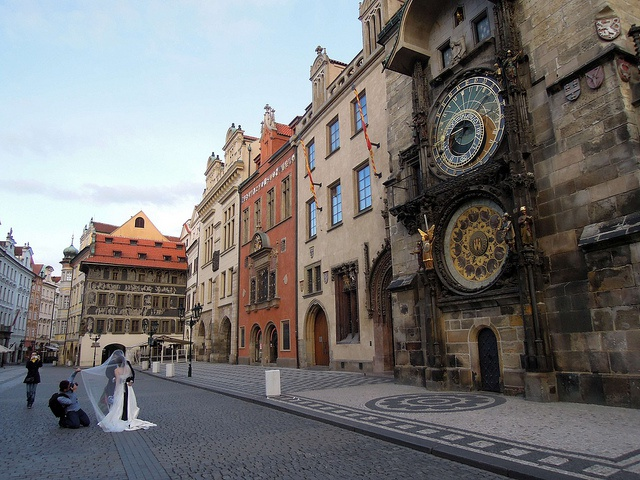Describe the objects in this image and their specific colors. I can see clock in lightblue, gray, black, darkgray, and maroon tones, clock in lightblue, black, and gray tones, people in lightblue, darkgray, lightgray, and gray tones, people in lightblue, black, gray, navy, and darkblue tones, and people in lightblue, black, gray, and blue tones in this image. 